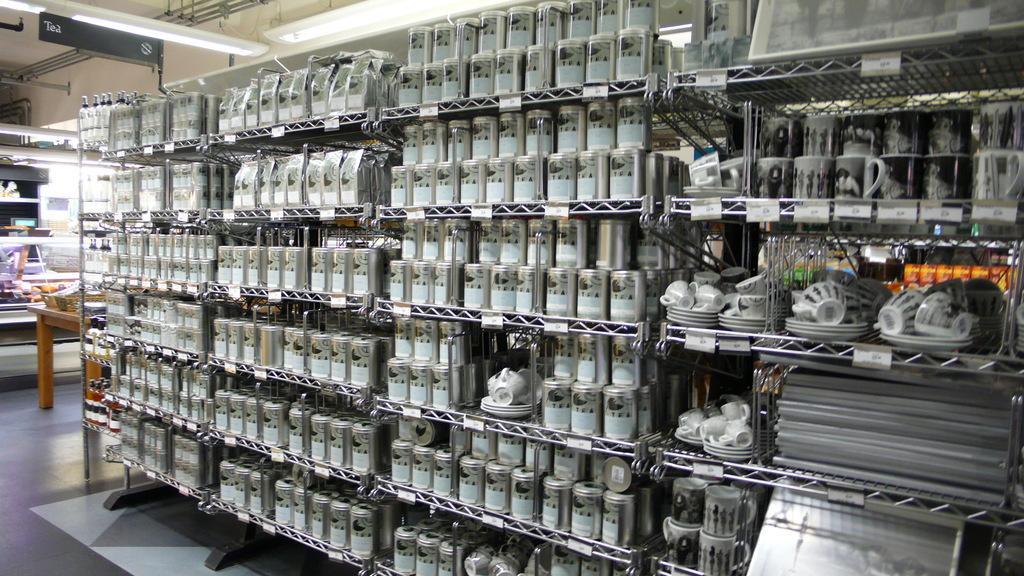Could you give a brief overview of what you see in this image? This picture shows few cups in the metal racks and we see few cups and saucers and a wooden table on the side and we see couple of lights and a name board to the roof. 